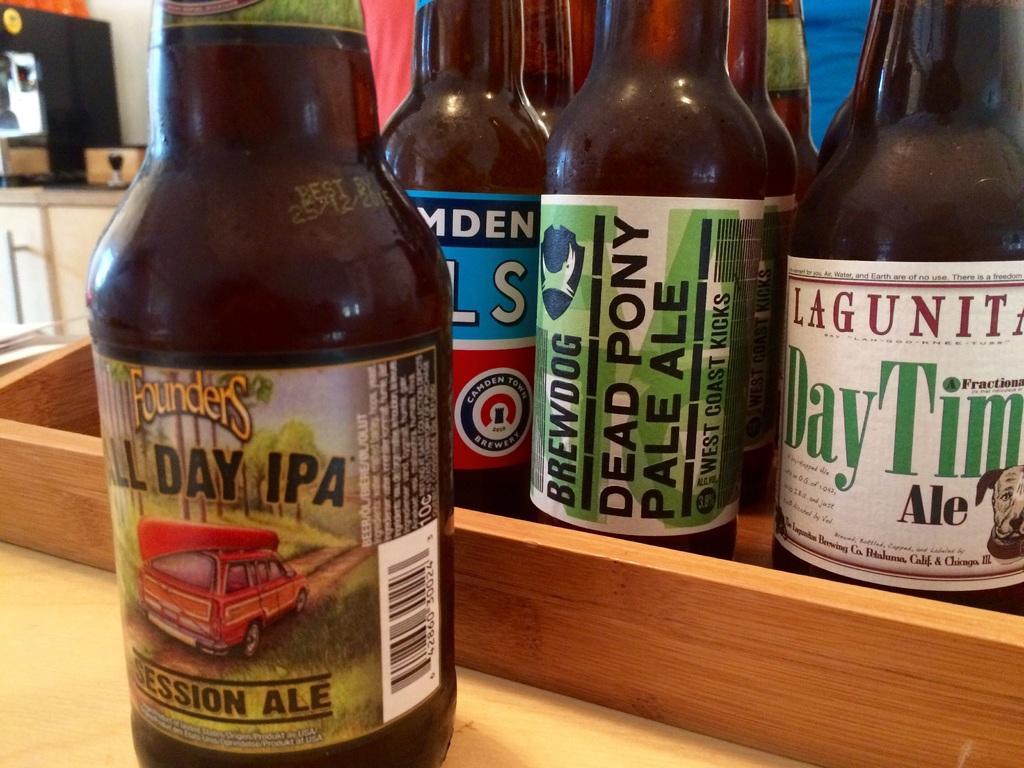<image>
Present a compact description of the photo's key features. Bottle of Founders All Day IPA in front of some other beer bottles. 